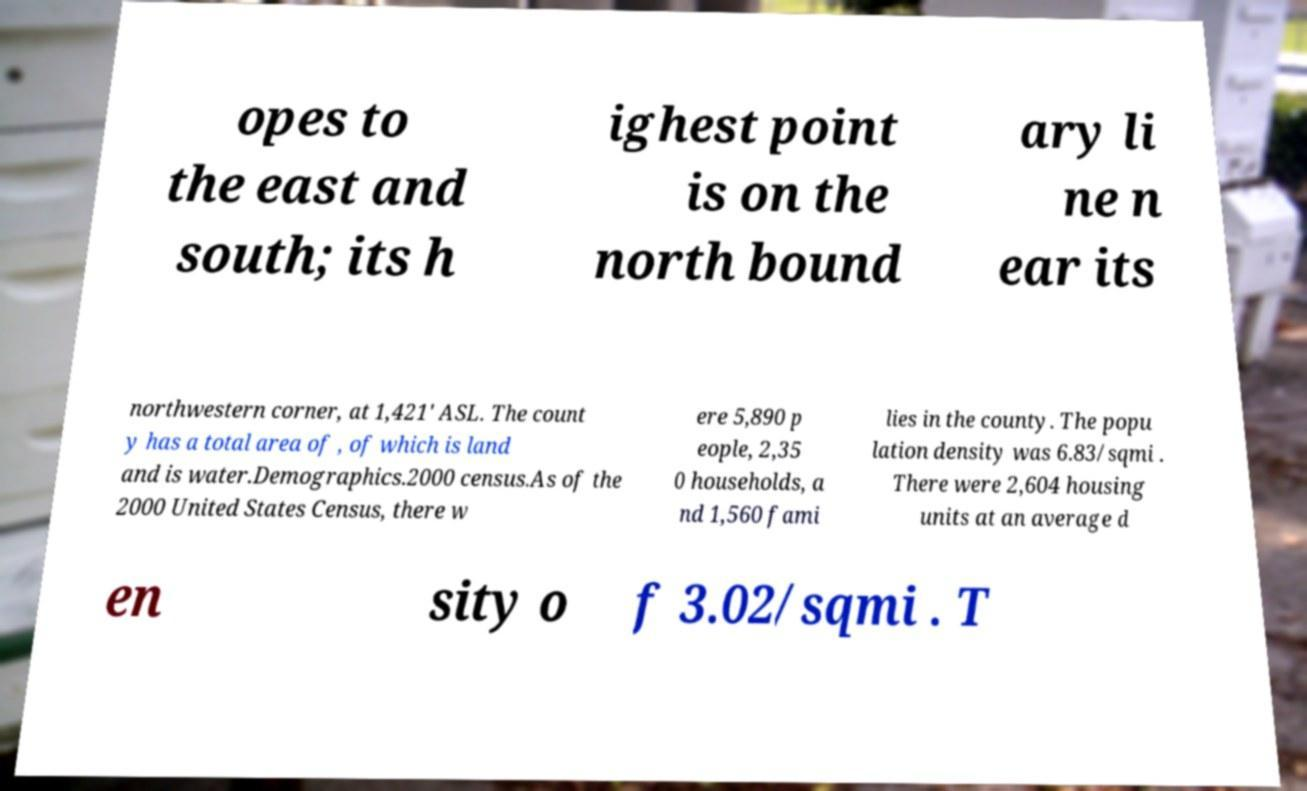Please read and relay the text visible in this image. What does it say? opes to the east and south; its h ighest point is on the north bound ary li ne n ear its northwestern corner, at 1,421' ASL. The count y has a total area of , of which is land and is water.Demographics.2000 census.As of the 2000 United States Census, there w ere 5,890 p eople, 2,35 0 households, a nd 1,560 fami lies in the county. The popu lation density was 6.83/sqmi . There were 2,604 housing units at an average d en sity o f 3.02/sqmi . T 